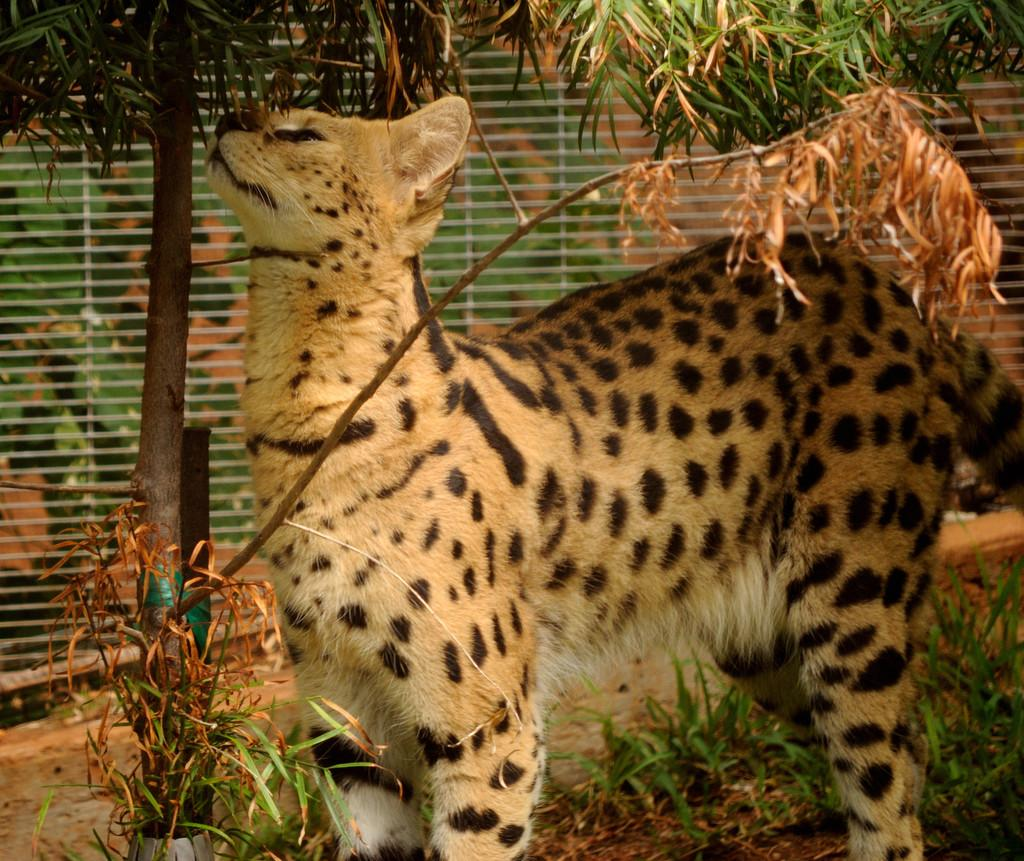What type of animal is in the image? There is a cheetah in the image. What type of vegetation is visible in the image? There is grass and plants visible in the image. What type of bottle can be seen in the image? There is no bottle present in the image. Is the cheetah in the image showing any signs of a wound? The image does not show any signs of a wound on the cheetah. 